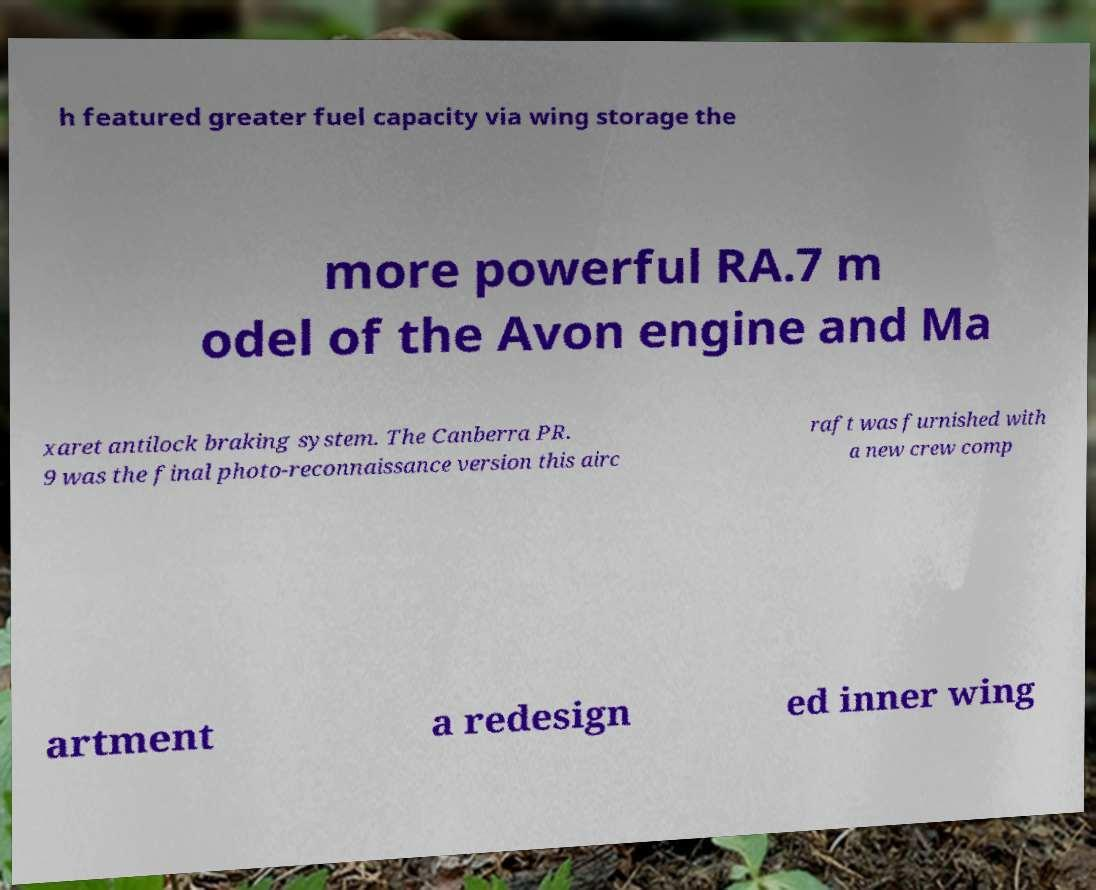Please read and relay the text visible in this image. What does it say? h featured greater fuel capacity via wing storage the more powerful RA.7 m odel of the Avon engine and Ma xaret antilock braking system. The Canberra PR. 9 was the final photo-reconnaissance version this airc raft was furnished with a new crew comp artment a redesign ed inner wing 